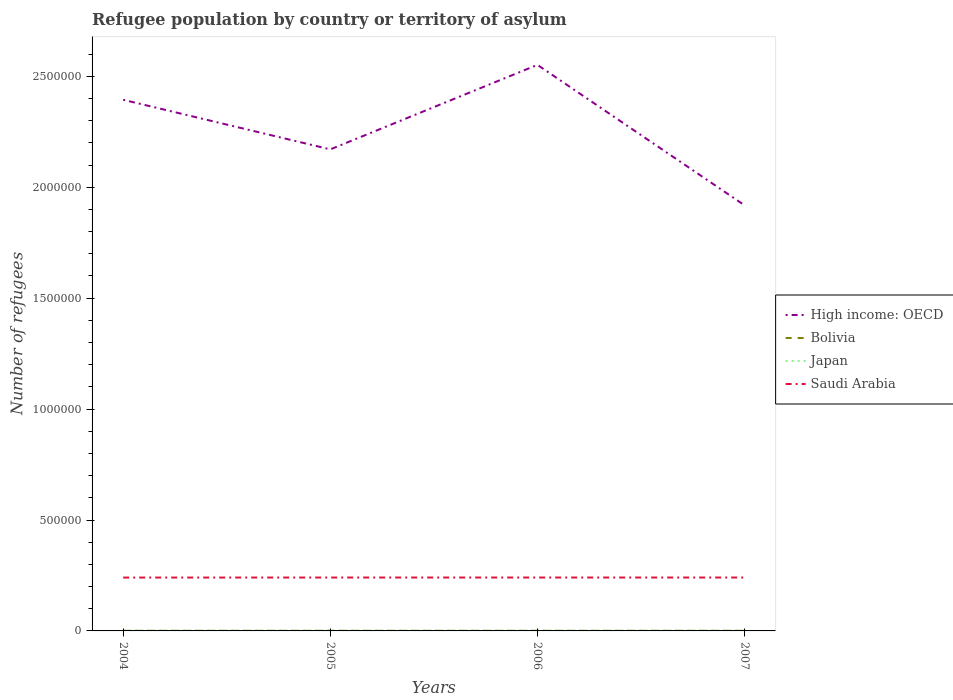How many different coloured lines are there?
Ensure brevity in your answer.  4. Does the line corresponding to Japan intersect with the line corresponding to High income: OECD?
Your answer should be very brief. No. Across all years, what is the maximum number of refugees in Saudi Arabia?
Provide a short and direct response. 2.41e+05. In which year was the number of refugees in High income: OECD maximum?
Your answer should be compact. 2007. What is the total number of refugees in Bolivia in the graph?
Your response must be concise. -32. What is the difference between the highest and the second highest number of refugees in High income: OECD?
Keep it short and to the point. 6.33e+05. What is the difference between the highest and the lowest number of refugees in Bolivia?
Your answer should be compact. 2. What is the difference between two consecutive major ticks on the Y-axis?
Ensure brevity in your answer.  5.00e+05. Does the graph contain any zero values?
Your response must be concise. No. Does the graph contain grids?
Keep it short and to the point. No. How are the legend labels stacked?
Offer a very short reply. Vertical. What is the title of the graph?
Your answer should be compact. Refugee population by country or territory of asylum. Does "Jordan" appear as one of the legend labels in the graph?
Provide a succinct answer. No. What is the label or title of the X-axis?
Ensure brevity in your answer.  Years. What is the label or title of the Y-axis?
Your answer should be very brief. Number of refugees. What is the Number of refugees in High income: OECD in 2004?
Your response must be concise. 2.39e+06. What is the Number of refugees of Bolivia in 2004?
Provide a short and direct response. 524. What is the Number of refugees in Japan in 2004?
Provide a short and direct response. 1967. What is the Number of refugees of Saudi Arabia in 2004?
Offer a very short reply. 2.41e+05. What is the Number of refugees of High income: OECD in 2005?
Provide a short and direct response. 2.17e+06. What is the Number of refugees in Bolivia in 2005?
Provide a short and direct response. 535. What is the Number of refugees of Japan in 2005?
Provide a short and direct response. 1941. What is the Number of refugees of Saudi Arabia in 2005?
Provide a short and direct response. 2.41e+05. What is the Number of refugees in High income: OECD in 2006?
Your response must be concise. 2.55e+06. What is the Number of refugees in Bolivia in 2006?
Offer a terse response. 567. What is the Number of refugees in Japan in 2006?
Keep it short and to the point. 1844. What is the Number of refugees in Saudi Arabia in 2006?
Offer a very short reply. 2.41e+05. What is the Number of refugees in High income: OECD in 2007?
Your answer should be very brief. 1.92e+06. What is the Number of refugees in Bolivia in 2007?
Your answer should be compact. 632. What is the Number of refugees in Japan in 2007?
Provide a succinct answer. 1794. What is the Number of refugees in Saudi Arabia in 2007?
Ensure brevity in your answer.  2.41e+05. Across all years, what is the maximum Number of refugees of High income: OECD?
Your answer should be compact. 2.55e+06. Across all years, what is the maximum Number of refugees in Bolivia?
Provide a short and direct response. 632. Across all years, what is the maximum Number of refugees in Japan?
Provide a succinct answer. 1967. Across all years, what is the maximum Number of refugees of Saudi Arabia?
Provide a succinct answer. 2.41e+05. Across all years, what is the minimum Number of refugees in High income: OECD?
Offer a very short reply. 1.92e+06. Across all years, what is the minimum Number of refugees of Bolivia?
Give a very brief answer. 524. Across all years, what is the minimum Number of refugees in Japan?
Your answer should be very brief. 1794. Across all years, what is the minimum Number of refugees in Saudi Arabia?
Your answer should be very brief. 2.41e+05. What is the total Number of refugees of High income: OECD in the graph?
Your response must be concise. 9.03e+06. What is the total Number of refugees of Bolivia in the graph?
Keep it short and to the point. 2258. What is the total Number of refugees of Japan in the graph?
Offer a terse response. 7546. What is the total Number of refugees in Saudi Arabia in the graph?
Ensure brevity in your answer.  9.63e+05. What is the difference between the Number of refugees in High income: OECD in 2004 and that in 2005?
Offer a very short reply. 2.23e+05. What is the difference between the Number of refugees of Bolivia in 2004 and that in 2005?
Offer a terse response. -11. What is the difference between the Number of refugees in Saudi Arabia in 2004 and that in 2005?
Offer a terse response. -149. What is the difference between the Number of refugees in High income: OECD in 2004 and that in 2006?
Offer a very short reply. -1.57e+05. What is the difference between the Number of refugees in Bolivia in 2004 and that in 2006?
Give a very brief answer. -43. What is the difference between the Number of refugees of Japan in 2004 and that in 2006?
Ensure brevity in your answer.  123. What is the difference between the Number of refugees in Saudi Arabia in 2004 and that in 2006?
Keep it short and to the point. -220. What is the difference between the Number of refugees of High income: OECD in 2004 and that in 2007?
Give a very brief answer. 4.76e+05. What is the difference between the Number of refugees in Bolivia in 2004 and that in 2007?
Offer a very short reply. -108. What is the difference between the Number of refugees of Japan in 2004 and that in 2007?
Your answer should be compact. 173. What is the difference between the Number of refugees in Saudi Arabia in 2004 and that in 2007?
Your answer should be compact. -190. What is the difference between the Number of refugees of High income: OECD in 2005 and that in 2006?
Ensure brevity in your answer.  -3.81e+05. What is the difference between the Number of refugees of Bolivia in 2005 and that in 2006?
Ensure brevity in your answer.  -32. What is the difference between the Number of refugees in Japan in 2005 and that in 2006?
Offer a very short reply. 97. What is the difference between the Number of refugees of Saudi Arabia in 2005 and that in 2006?
Make the answer very short. -71. What is the difference between the Number of refugees of High income: OECD in 2005 and that in 2007?
Keep it short and to the point. 2.52e+05. What is the difference between the Number of refugees in Bolivia in 2005 and that in 2007?
Offer a terse response. -97. What is the difference between the Number of refugees of Japan in 2005 and that in 2007?
Your answer should be compact. 147. What is the difference between the Number of refugees of Saudi Arabia in 2005 and that in 2007?
Offer a terse response. -41. What is the difference between the Number of refugees of High income: OECD in 2006 and that in 2007?
Your answer should be compact. 6.33e+05. What is the difference between the Number of refugees in Bolivia in 2006 and that in 2007?
Your response must be concise. -65. What is the difference between the Number of refugees of Saudi Arabia in 2006 and that in 2007?
Give a very brief answer. 30. What is the difference between the Number of refugees of High income: OECD in 2004 and the Number of refugees of Bolivia in 2005?
Give a very brief answer. 2.39e+06. What is the difference between the Number of refugees of High income: OECD in 2004 and the Number of refugees of Japan in 2005?
Offer a very short reply. 2.39e+06. What is the difference between the Number of refugees in High income: OECD in 2004 and the Number of refugees in Saudi Arabia in 2005?
Ensure brevity in your answer.  2.15e+06. What is the difference between the Number of refugees in Bolivia in 2004 and the Number of refugees in Japan in 2005?
Provide a succinct answer. -1417. What is the difference between the Number of refugees of Bolivia in 2004 and the Number of refugees of Saudi Arabia in 2005?
Provide a short and direct response. -2.40e+05. What is the difference between the Number of refugees in Japan in 2004 and the Number of refugees in Saudi Arabia in 2005?
Offer a very short reply. -2.39e+05. What is the difference between the Number of refugees of High income: OECD in 2004 and the Number of refugees of Bolivia in 2006?
Offer a terse response. 2.39e+06. What is the difference between the Number of refugees of High income: OECD in 2004 and the Number of refugees of Japan in 2006?
Offer a terse response. 2.39e+06. What is the difference between the Number of refugees of High income: OECD in 2004 and the Number of refugees of Saudi Arabia in 2006?
Offer a terse response. 2.15e+06. What is the difference between the Number of refugees in Bolivia in 2004 and the Number of refugees in Japan in 2006?
Make the answer very short. -1320. What is the difference between the Number of refugees in Bolivia in 2004 and the Number of refugees in Saudi Arabia in 2006?
Your response must be concise. -2.40e+05. What is the difference between the Number of refugees in Japan in 2004 and the Number of refugees in Saudi Arabia in 2006?
Offer a terse response. -2.39e+05. What is the difference between the Number of refugees of High income: OECD in 2004 and the Number of refugees of Bolivia in 2007?
Your answer should be very brief. 2.39e+06. What is the difference between the Number of refugees in High income: OECD in 2004 and the Number of refugees in Japan in 2007?
Ensure brevity in your answer.  2.39e+06. What is the difference between the Number of refugees in High income: OECD in 2004 and the Number of refugees in Saudi Arabia in 2007?
Give a very brief answer. 2.15e+06. What is the difference between the Number of refugees in Bolivia in 2004 and the Number of refugees in Japan in 2007?
Give a very brief answer. -1270. What is the difference between the Number of refugees of Bolivia in 2004 and the Number of refugees of Saudi Arabia in 2007?
Offer a terse response. -2.40e+05. What is the difference between the Number of refugees of Japan in 2004 and the Number of refugees of Saudi Arabia in 2007?
Ensure brevity in your answer.  -2.39e+05. What is the difference between the Number of refugees of High income: OECD in 2005 and the Number of refugees of Bolivia in 2006?
Make the answer very short. 2.17e+06. What is the difference between the Number of refugees in High income: OECD in 2005 and the Number of refugees in Japan in 2006?
Keep it short and to the point. 2.17e+06. What is the difference between the Number of refugees in High income: OECD in 2005 and the Number of refugees in Saudi Arabia in 2006?
Provide a short and direct response. 1.93e+06. What is the difference between the Number of refugees of Bolivia in 2005 and the Number of refugees of Japan in 2006?
Your response must be concise. -1309. What is the difference between the Number of refugees of Bolivia in 2005 and the Number of refugees of Saudi Arabia in 2006?
Offer a very short reply. -2.40e+05. What is the difference between the Number of refugees of Japan in 2005 and the Number of refugees of Saudi Arabia in 2006?
Keep it short and to the point. -2.39e+05. What is the difference between the Number of refugees of High income: OECD in 2005 and the Number of refugees of Bolivia in 2007?
Provide a succinct answer. 2.17e+06. What is the difference between the Number of refugees in High income: OECD in 2005 and the Number of refugees in Japan in 2007?
Keep it short and to the point. 2.17e+06. What is the difference between the Number of refugees of High income: OECD in 2005 and the Number of refugees of Saudi Arabia in 2007?
Give a very brief answer. 1.93e+06. What is the difference between the Number of refugees in Bolivia in 2005 and the Number of refugees in Japan in 2007?
Ensure brevity in your answer.  -1259. What is the difference between the Number of refugees in Bolivia in 2005 and the Number of refugees in Saudi Arabia in 2007?
Provide a short and direct response. -2.40e+05. What is the difference between the Number of refugees in Japan in 2005 and the Number of refugees in Saudi Arabia in 2007?
Keep it short and to the point. -2.39e+05. What is the difference between the Number of refugees in High income: OECD in 2006 and the Number of refugees in Bolivia in 2007?
Your answer should be very brief. 2.55e+06. What is the difference between the Number of refugees in High income: OECD in 2006 and the Number of refugees in Japan in 2007?
Offer a terse response. 2.55e+06. What is the difference between the Number of refugees of High income: OECD in 2006 and the Number of refugees of Saudi Arabia in 2007?
Give a very brief answer. 2.31e+06. What is the difference between the Number of refugees in Bolivia in 2006 and the Number of refugees in Japan in 2007?
Your answer should be compact. -1227. What is the difference between the Number of refugees in Bolivia in 2006 and the Number of refugees in Saudi Arabia in 2007?
Give a very brief answer. -2.40e+05. What is the difference between the Number of refugees of Japan in 2006 and the Number of refugees of Saudi Arabia in 2007?
Provide a short and direct response. -2.39e+05. What is the average Number of refugees of High income: OECD per year?
Ensure brevity in your answer.  2.26e+06. What is the average Number of refugees of Bolivia per year?
Offer a terse response. 564.5. What is the average Number of refugees in Japan per year?
Provide a succinct answer. 1886.5. What is the average Number of refugees in Saudi Arabia per year?
Offer a very short reply. 2.41e+05. In the year 2004, what is the difference between the Number of refugees in High income: OECD and Number of refugees in Bolivia?
Offer a terse response. 2.39e+06. In the year 2004, what is the difference between the Number of refugees of High income: OECD and Number of refugees of Japan?
Your response must be concise. 2.39e+06. In the year 2004, what is the difference between the Number of refugees of High income: OECD and Number of refugees of Saudi Arabia?
Your response must be concise. 2.15e+06. In the year 2004, what is the difference between the Number of refugees of Bolivia and Number of refugees of Japan?
Offer a terse response. -1443. In the year 2004, what is the difference between the Number of refugees in Bolivia and Number of refugees in Saudi Arabia?
Make the answer very short. -2.40e+05. In the year 2004, what is the difference between the Number of refugees of Japan and Number of refugees of Saudi Arabia?
Ensure brevity in your answer.  -2.39e+05. In the year 2005, what is the difference between the Number of refugees in High income: OECD and Number of refugees in Bolivia?
Provide a succinct answer. 2.17e+06. In the year 2005, what is the difference between the Number of refugees of High income: OECD and Number of refugees of Japan?
Make the answer very short. 2.17e+06. In the year 2005, what is the difference between the Number of refugees in High income: OECD and Number of refugees in Saudi Arabia?
Provide a short and direct response. 1.93e+06. In the year 2005, what is the difference between the Number of refugees of Bolivia and Number of refugees of Japan?
Your answer should be compact. -1406. In the year 2005, what is the difference between the Number of refugees in Bolivia and Number of refugees in Saudi Arabia?
Keep it short and to the point. -2.40e+05. In the year 2005, what is the difference between the Number of refugees in Japan and Number of refugees in Saudi Arabia?
Provide a short and direct response. -2.39e+05. In the year 2006, what is the difference between the Number of refugees in High income: OECD and Number of refugees in Bolivia?
Your answer should be very brief. 2.55e+06. In the year 2006, what is the difference between the Number of refugees in High income: OECD and Number of refugees in Japan?
Offer a very short reply. 2.55e+06. In the year 2006, what is the difference between the Number of refugees of High income: OECD and Number of refugees of Saudi Arabia?
Your response must be concise. 2.31e+06. In the year 2006, what is the difference between the Number of refugees of Bolivia and Number of refugees of Japan?
Offer a terse response. -1277. In the year 2006, what is the difference between the Number of refugees in Bolivia and Number of refugees in Saudi Arabia?
Your answer should be very brief. -2.40e+05. In the year 2006, what is the difference between the Number of refugees in Japan and Number of refugees in Saudi Arabia?
Your answer should be very brief. -2.39e+05. In the year 2007, what is the difference between the Number of refugees in High income: OECD and Number of refugees in Bolivia?
Ensure brevity in your answer.  1.92e+06. In the year 2007, what is the difference between the Number of refugees of High income: OECD and Number of refugees of Japan?
Offer a very short reply. 1.92e+06. In the year 2007, what is the difference between the Number of refugees of High income: OECD and Number of refugees of Saudi Arabia?
Give a very brief answer. 1.68e+06. In the year 2007, what is the difference between the Number of refugees in Bolivia and Number of refugees in Japan?
Provide a succinct answer. -1162. In the year 2007, what is the difference between the Number of refugees of Bolivia and Number of refugees of Saudi Arabia?
Make the answer very short. -2.40e+05. In the year 2007, what is the difference between the Number of refugees in Japan and Number of refugees in Saudi Arabia?
Provide a short and direct response. -2.39e+05. What is the ratio of the Number of refugees of High income: OECD in 2004 to that in 2005?
Offer a very short reply. 1.1. What is the ratio of the Number of refugees of Bolivia in 2004 to that in 2005?
Your answer should be very brief. 0.98. What is the ratio of the Number of refugees of Japan in 2004 to that in 2005?
Make the answer very short. 1.01. What is the ratio of the Number of refugees of Saudi Arabia in 2004 to that in 2005?
Offer a terse response. 1. What is the ratio of the Number of refugees of High income: OECD in 2004 to that in 2006?
Offer a very short reply. 0.94. What is the ratio of the Number of refugees in Bolivia in 2004 to that in 2006?
Provide a short and direct response. 0.92. What is the ratio of the Number of refugees of Japan in 2004 to that in 2006?
Provide a succinct answer. 1.07. What is the ratio of the Number of refugees in High income: OECD in 2004 to that in 2007?
Your answer should be very brief. 1.25. What is the ratio of the Number of refugees in Bolivia in 2004 to that in 2007?
Provide a succinct answer. 0.83. What is the ratio of the Number of refugees of Japan in 2004 to that in 2007?
Give a very brief answer. 1.1. What is the ratio of the Number of refugees in Saudi Arabia in 2004 to that in 2007?
Keep it short and to the point. 1. What is the ratio of the Number of refugees in High income: OECD in 2005 to that in 2006?
Ensure brevity in your answer.  0.85. What is the ratio of the Number of refugees of Bolivia in 2005 to that in 2006?
Give a very brief answer. 0.94. What is the ratio of the Number of refugees of Japan in 2005 to that in 2006?
Offer a terse response. 1.05. What is the ratio of the Number of refugees of Saudi Arabia in 2005 to that in 2006?
Provide a succinct answer. 1. What is the ratio of the Number of refugees of High income: OECD in 2005 to that in 2007?
Offer a terse response. 1.13. What is the ratio of the Number of refugees in Bolivia in 2005 to that in 2007?
Offer a terse response. 0.85. What is the ratio of the Number of refugees of Japan in 2005 to that in 2007?
Ensure brevity in your answer.  1.08. What is the ratio of the Number of refugees in High income: OECD in 2006 to that in 2007?
Your answer should be very brief. 1.33. What is the ratio of the Number of refugees of Bolivia in 2006 to that in 2007?
Ensure brevity in your answer.  0.9. What is the ratio of the Number of refugees in Japan in 2006 to that in 2007?
Provide a short and direct response. 1.03. What is the ratio of the Number of refugees of Saudi Arabia in 2006 to that in 2007?
Give a very brief answer. 1. What is the difference between the highest and the second highest Number of refugees of High income: OECD?
Keep it short and to the point. 1.57e+05. What is the difference between the highest and the second highest Number of refugees in Bolivia?
Offer a terse response. 65. What is the difference between the highest and the lowest Number of refugees of High income: OECD?
Ensure brevity in your answer.  6.33e+05. What is the difference between the highest and the lowest Number of refugees in Bolivia?
Your response must be concise. 108. What is the difference between the highest and the lowest Number of refugees of Japan?
Offer a very short reply. 173. What is the difference between the highest and the lowest Number of refugees of Saudi Arabia?
Provide a succinct answer. 220. 